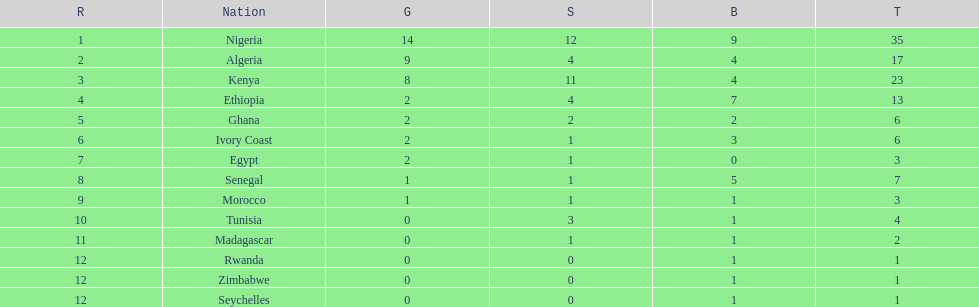The country that won the most medals was? Nigeria. 